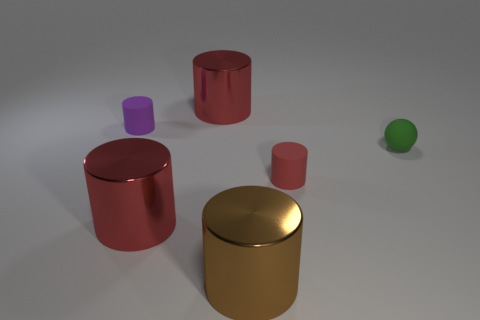Does the tiny cylinder that is behind the tiny red matte object have the same color as the small matte ball?
Offer a terse response. No. Are there fewer large green shiny cylinders than tiny things?
Keep it short and to the point. Yes. What number of other objects are there of the same color as the ball?
Your answer should be very brief. 0. Do the red cylinder behind the small red rubber cylinder and the small red thing have the same material?
Ensure brevity in your answer.  No. What is the material of the big red cylinder that is in front of the tiny rubber ball?
Provide a succinct answer. Metal. There is a metallic thing that is behind the tiny green sphere to the right of the purple cylinder; what size is it?
Your answer should be very brief. Large. Are there any red things made of the same material as the green sphere?
Your response must be concise. Yes. There is a green thing that is in front of the tiny thing that is to the left of the red metal cylinder in front of the small purple matte cylinder; what shape is it?
Give a very brief answer. Sphere. There is a thing to the right of the small red cylinder; does it have the same color as the large cylinder that is behind the ball?
Offer a terse response. No. Is there anything else that is the same size as the purple rubber object?
Offer a terse response. Yes. 